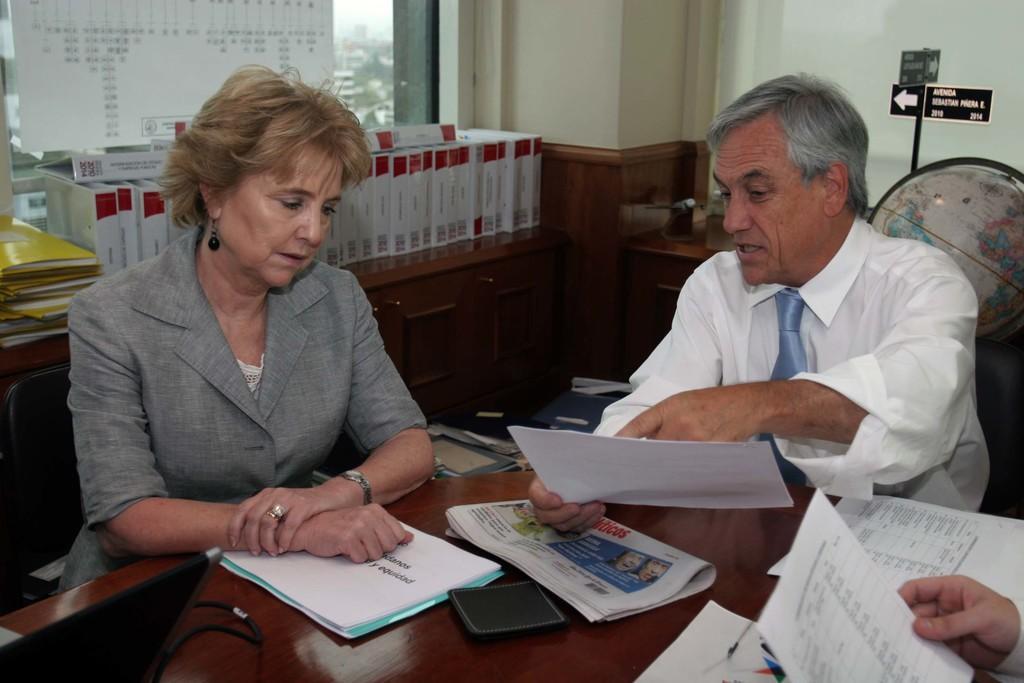Could you give a brief overview of what you see in this image? In this picture we can see a man sitting on the chair and holding a paper in his hand. There is a woman who is also sitting on the chair. We can see newspaper, few papers and a wallet on the table. There is a person holding a paper in his hand on bottom right. There are few books and files on a wooden desk. There is a signboard(arrow sign) on the stand. We can see a globe in the background. 